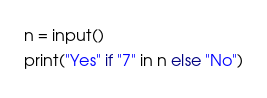<code> <loc_0><loc_0><loc_500><loc_500><_Python_>n = input()
print("Yes" if "7" in n else "No")</code> 